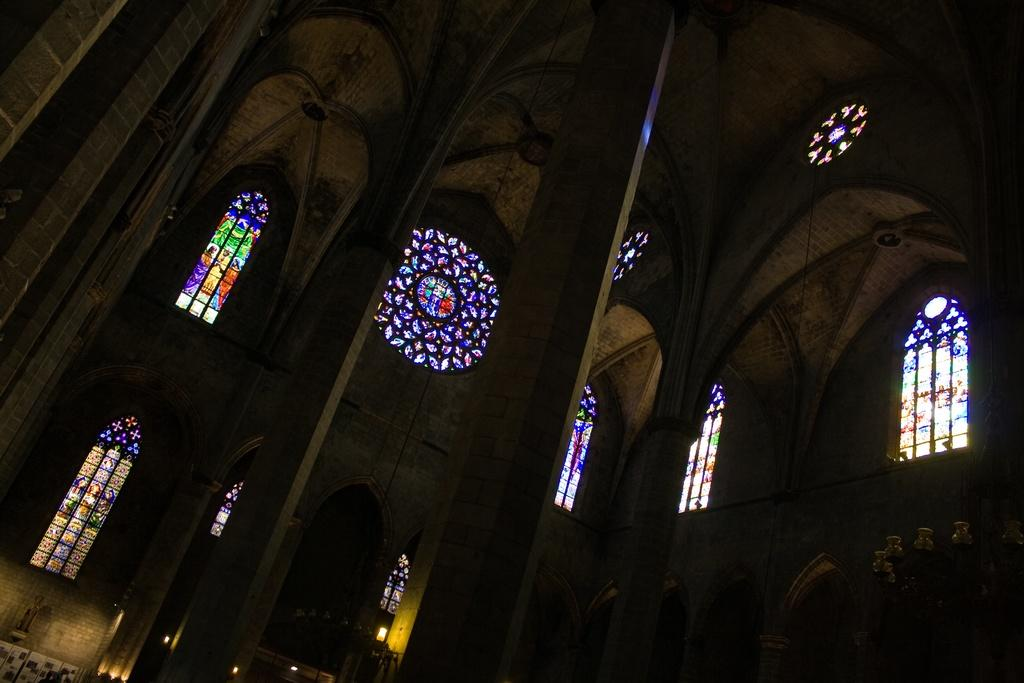What type of location is depicted in the image? The image shows the inside view of a building. What architectural features can be seen in the image? There are pillars visible in the image. What type of windows are present in the building? There are windows with glass doors in the image. What decorative elements are present on the windows? Glass paintings are present on the windows. What type of dress is the knowledge wearing in the image? There is no person or concept of knowledge present in the image; it depicts the interior of a building with architectural features and decorative elements. 